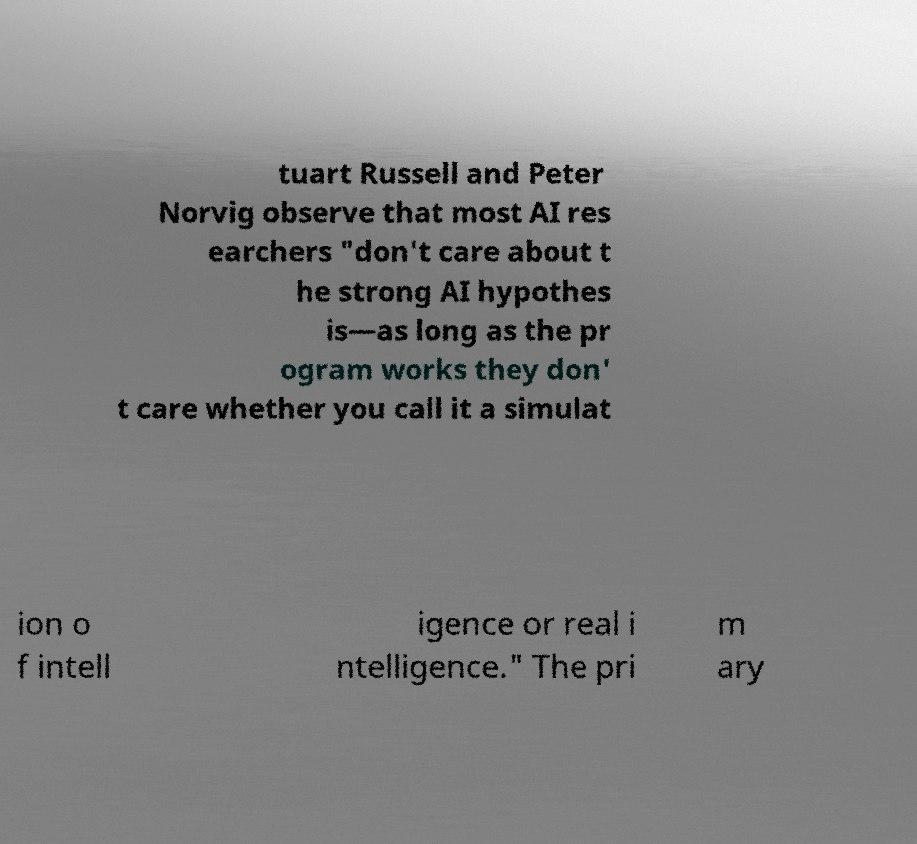Could you extract and type out the text from this image? tuart Russell and Peter Norvig observe that most AI res earchers "don't care about t he strong AI hypothes is—as long as the pr ogram works they don' t care whether you call it a simulat ion o f intell igence or real i ntelligence." The pri m ary 